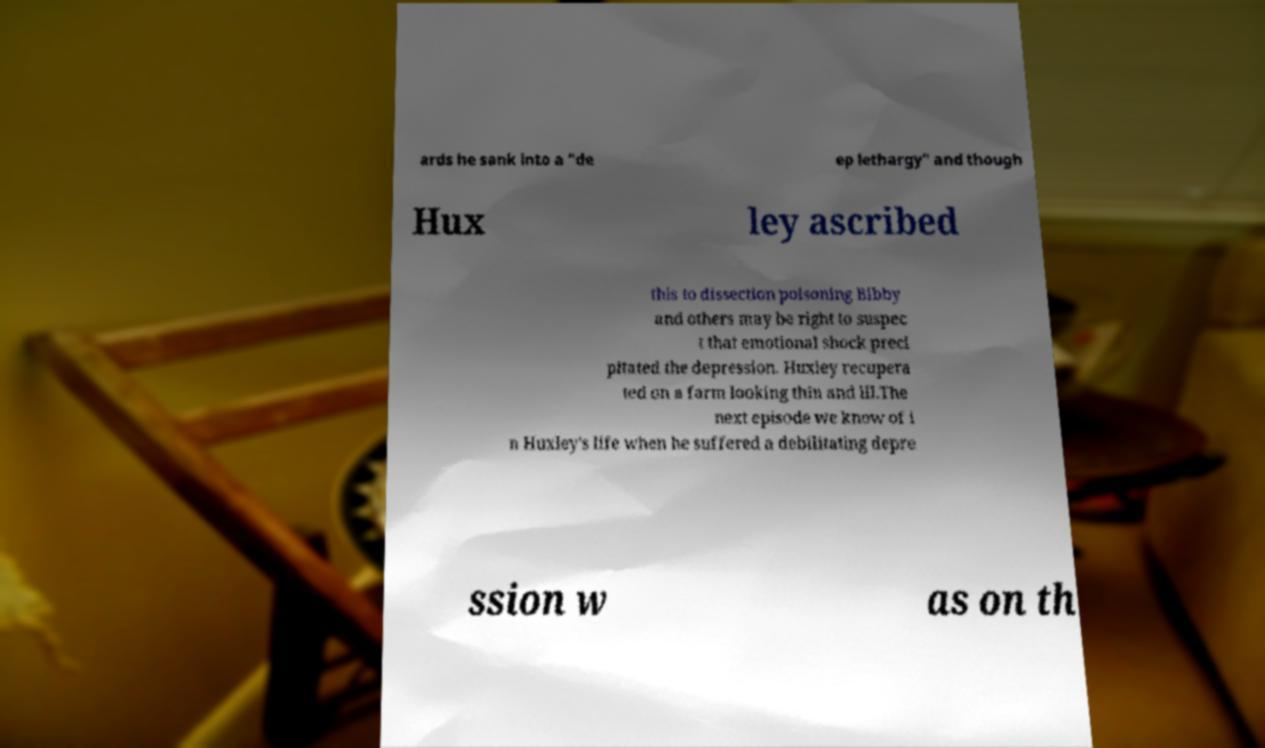Please identify and transcribe the text found in this image. ards he sank into a "de ep lethargy" and though Hux ley ascribed this to dissection poisoning Bibby and others may be right to suspec t that emotional shock preci pitated the depression. Huxley recupera ted on a farm looking thin and ill.The next episode we know of i n Huxley's life when he suffered a debilitating depre ssion w as on th 